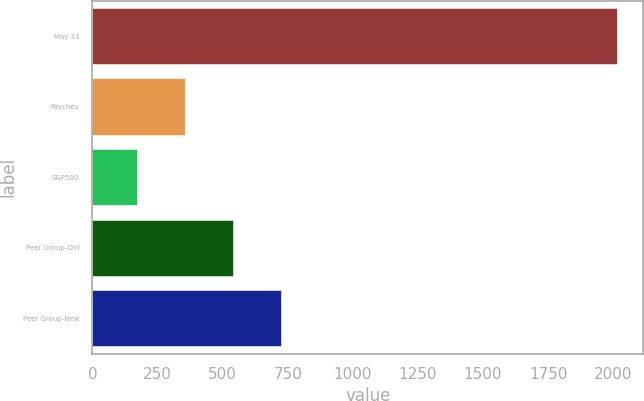<chart> <loc_0><loc_0><loc_500><loc_500><bar_chart><fcel>May 31<fcel>Paychex<fcel>S&P500<fcel>Peer Group-Old<fcel>Peer Group-New<nl><fcel>2015<fcel>355.76<fcel>171.4<fcel>540.12<fcel>724.48<nl></chart> 